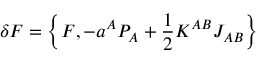<formula> <loc_0><loc_0><loc_500><loc_500>\delta F = \left \{ F , - a ^ { A } P _ { A } + \frac { 1 } { 2 } K ^ { A B } J _ { A B } \right \}</formula> 